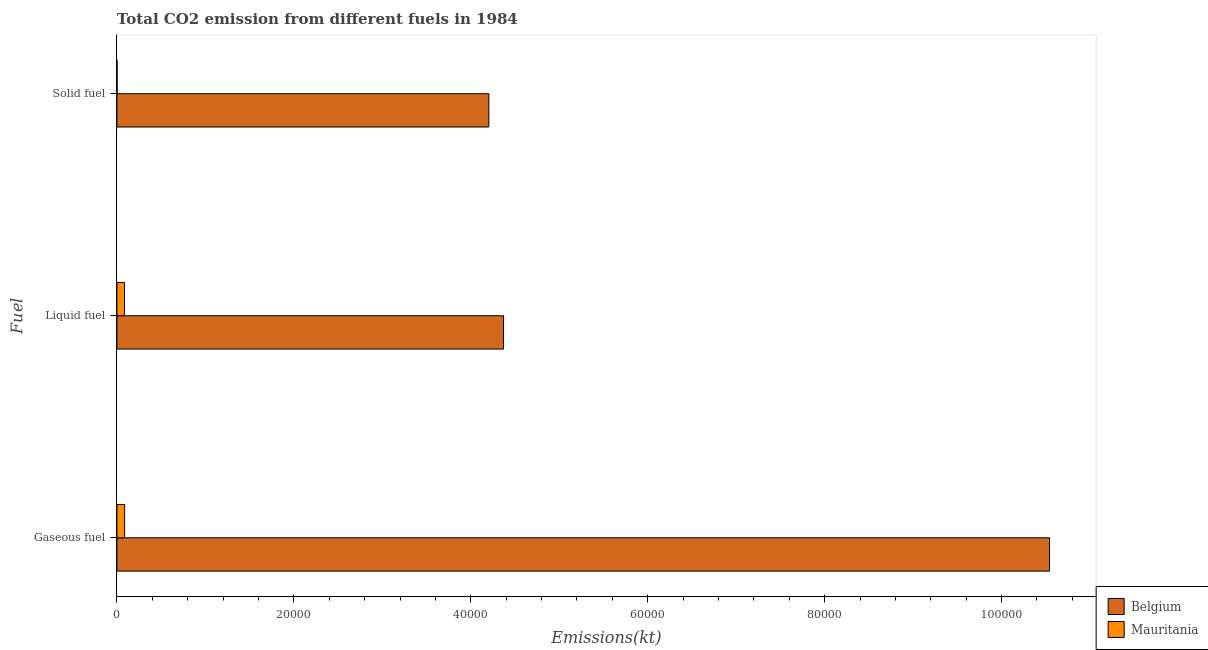Are the number of bars on each tick of the Y-axis equal?
Keep it short and to the point. Yes. How many bars are there on the 3rd tick from the top?
Ensure brevity in your answer.  2. What is the label of the 2nd group of bars from the top?
Keep it short and to the point. Liquid fuel. What is the amount of co2 emissions from liquid fuel in Mauritania?
Give a very brief answer. 854.41. Across all countries, what is the maximum amount of co2 emissions from solid fuel?
Offer a very short reply. 4.20e+04. Across all countries, what is the minimum amount of co2 emissions from liquid fuel?
Give a very brief answer. 854.41. In which country was the amount of co2 emissions from solid fuel minimum?
Make the answer very short. Mauritania. What is the total amount of co2 emissions from liquid fuel in the graph?
Your answer should be very brief. 4.46e+04. What is the difference between the amount of co2 emissions from gaseous fuel in Belgium and that in Mauritania?
Make the answer very short. 1.05e+05. What is the difference between the amount of co2 emissions from liquid fuel in Belgium and the amount of co2 emissions from solid fuel in Mauritania?
Ensure brevity in your answer.  4.37e+04. What is the average amount of co2 emissions from solid fuel per country?
Your answer should be compact. 2.10e+04. What is the difference between the amount of co2 emissions from gaseous fuel and amount of co2 emissions from liquid fuel in Mauritania?
Give a very brief answer. 18.34. In how many countries, is the amount of co2 emissions from liquid fuel greater than 56000 kt?
Provide a succinct answer. 0. What is the ratio of the amount of co2 emissions from gaseous fuel in Belgium to that in Mauritania?
Keep it short and to the point. 120.79. Is the amount of co2 emissions from liquid fuel in Belgium less than that in Mauritania?
Make the answer very short. No. Is the difference between the amount of co2 emissions from solid fuel in Mauritania and Belgium greater than the difference between the amount of co2 emissions from liquid fuel in Mauritania and Belgium?
Offer a very short reply. Yes. What is the difference between the highest and the second highest amount of co2 emissions from liquid fuel?
Provide a short and direct response. 4.29e+04. What is the difference between the highest and the lowest amount of co2 emissions from gaseous fuel?
Provide a short and direct response. 1.05e+05. In how many countries, is the amount of co2 emissions from solid fuel greater than the average amount of co2 emissions from solid fuel taken over all countries?
Your answer should be very brief. 1. What does the 1st bar from the top in Solid fuel represents?
Offer a very short reply. Mauritania. What does the 1st bar from the bottom in Solid fuel represents?
Your answer should be very brief. Belgium. Is it the case that in every country, the sum of the amount of co2 emissions from gaseous fuel and amount of co2 emissions from liquid fuel is greater than the amount of co2 emissions from solid fuel?
Your answer should be compact. Yes. How many countries are there in the graph?
Ensure brevity in your answer.  2. Are the values on the major ticks of X-axis written in scientific E-notation?
Give a very brief answer. No. Does the graph contain any zero values?
Provide a short and direct response. No. Where does the legend appear in the graph?
Give a very brief answer. Bottom right. How many legend labels are there?
Ensure brevity in your answer.  2. What is the title of the graph?
Your response must be concise. Total CO2 emission from different fuels in 1984. Does "Other small states" appear as one of the legend labels in the graph?
Give a very brief answer. No. What is the label or title of the X-axis?
Offer a very short reply. Emissions(kt). What is the label or title of the Y-axis?
Provide a succinct answer. Fuel. What is the Emissions(kt) in Belgium in Gaseous fuel?
Make the answer very short. 1.05e+05. What is the Emissions(kt) of Mauritania in Gaseous fuel?
Offer a terse response. 872.75. What is the Emissions(kt) in Belgium in Liquid fuel?
Make the answer very short. 4.37e+04. What is the Emissions(kt) in Mauritania in Liquid fuel?
Make the answer very short. 854.41. What is the Emissions(kt) in Belgium in Solid fuel?
Ensure brevity in your answer.  4.20e+04. What is the Emissions(kt) of Mauritania in Solid fuel?
Your answer should be very brief. 18.34. Across all Fuel, what is the maximum Emissions(kt) of Belgium?
Offer a terse response. 1.05e+05. Across all Fuel, what is the maximum Emissions(kt) in Mauritania?
Ensure brevity in your answer.  872.75. Across all Fuel, what is the minimum Emissions(kt) in Belgium?
Give a very brief answer. 4.20e+04. Across all Fuel, what is the minimum Emissions(kt) of Mauritania?
Give a very brief answer. 18.34. What is the total Emissions(kt) of Belgium in the graph?
Make the answer very short. 1.91e+05. What is the total Emissions(kt) in Mauritania in the graph?
Ensure brevity in your answer.  1745.49. What is the difference between the Emissions(kt) of Belgium in Gaseous fuel and that in Liquid fuel?
Your response must be concise. 6.17e+04. What is the difference between the Emissions(kt) in Mauritania in Gaseous fuel and that in Liquid fuel?
Give a very brief answer. 18.34. What is the difference between the Emissions(kt) in Belgium in Gaseous fuel and that in Solid fuel?
Provide a short and direct response. 6.34e+04. What is the difference between the Emissions(kt) in Mauritania in Gaseous fuel and that in Solid fuel?
Your response must be concise. 854.41. What is the difference between the Emissions(kt) of Belgium in Liquid fuel and that in Solid fuel?
Provide a short and direct response. 1664.82. What is the difference between the Emissions(kt) of Mauritania in Liquid fuel and that in Solid fuel?
Make the answer very short. 836.08. What is the difference between the Emissions(kt) in Belgium in Gaseous fuel and the Emissions(kt) in Mauritania in Liquid fuel?
Your response must be concise. 1.05e+05. What is the difference between the Emissions(kt) in Belgium in Gaseous fuel and the Emissions(kt) in Mauritania in Solid fuel?
Keep it short and to the point. 1.05e+05. What is the difference between the Emissions(kt) in Belgium in Liquid fuel and the Emissions(kt) in Mauritania in Solid fuel?
Your answer should be very brief. 4.37e+04. What is the average Emissions(kt) in Belgium per Fuel?
Keep it short and to the point. 6.37e+04. What is the average Emissions(kt) in Mauritania per Fuel?
Make the answer very short. 581.83. What is the difference between the Emissions(kt) in Belgium and Emissions(kt) in Mauritania in Gaseous fuel?
Offer a terse response. 1.05e+05. What is the difference between the Emissions(kt) in Belgium and Emissions(kt) in Mauritania in Liquid fuel?
Keep it short and to the point. 4.29e+04. What is the difference between the Emissions(kt) of Belgium and Emissions(kt) of Mauritania in Solid fuel?
Offer a very short reply. 4.20e+04. What is the ratio of the Emissions(kt) in Belgium in Gaseous fuel to that in Liquid fuel?
Provide a short and direct response. 2.41. What is the ratio of the Emissions(kt) of Mauritania in Gaseous fuel to that in Liquid fuel?
Your answer should be compact. 1.02. What is the ratio of the Emissions(kt) in Belgium in Gaseous fuel to that in Solid fuel?
Offer a terse response. 2.51. What is the ratio of the Emissions(kt) of Mauritania in Gaseous fuel to that in Solid fuel?
Give a very brief answer. 47.6. What is the ratio of the Emissions(kt) in Belgium in Liquid fuel to that in Solid fuel?
Keep it short and to the point. 1.04. What is the ratio of the Emissions(kt) in Mauritania in Liquid fuel to that in Solid fuel?
Ensure brevity in your answer.  46.6. What is the difference between the highest and the second highest Emissions(kt) of Belgium?
Keep it short and to the point. 6.17e+04. What is the difference between the highest and the second highest Emissions(kt) in Mauritania?
Give a very brief answer. 18.34. What is the difference between the highest and the lowest Emissions(kt) of Belgium?
Provide a succinct answer. 6.34e+04. What is the difference between the highest and the lowest Emissions(kt) of Mauritania?
Provide a short and direct response. 854.41. 